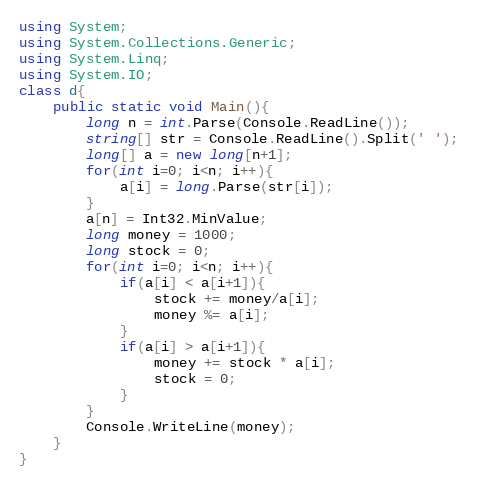Convert code to text. <code><loc_0><loc_0><loc_500><loc_500><_C#_>using System;
using System.Collections.Generic;
using System.Linq;
using System.IO;
class d{
    public static void Main(){
        long n = int.Parse(Console.ReadLine());
        string[] str = Console.ReadLine().Split(' ');
        long[] a = new long[n+1];
        for(int i=0; i<n; i++){
            a[i] = long.Parse(str[i]);
        }
        a[n] = Int32.MinValue;
        long money = 1000;
        long stock = 0;
        for(int i=0; i<n; i++){
            if(a[i] < a[i+1]){
                stock += money/a[i];
                money %= a[i];
            }
            if(a[i] > a[i+1]){
                money += stock * a[i];
                stock = 0;
            }
        }
        Console.WriteLine(money);
    }
}
</code> 